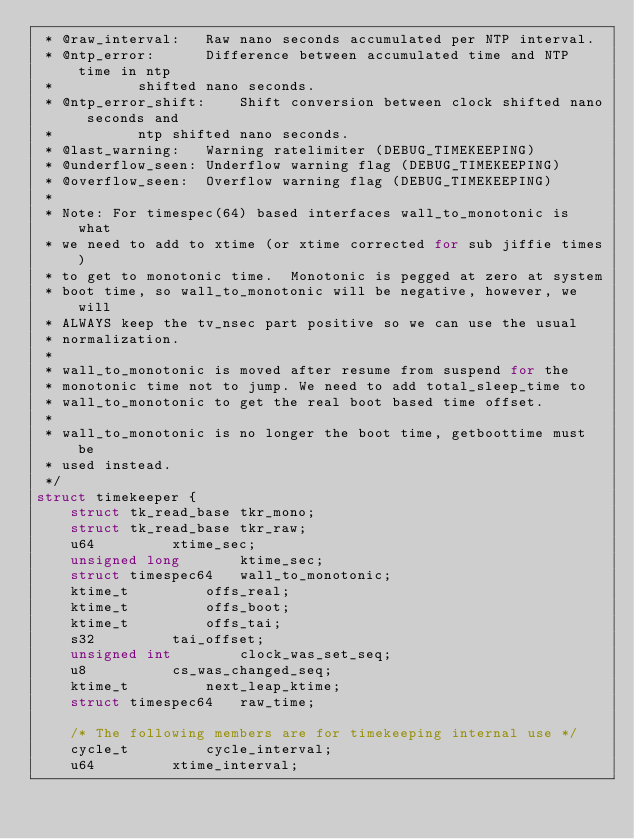Convert code to text. <code><loc_0><loc_0><loc_500><loc_500><_C_> * @raw_interval:	Raw nano seconds accumulated per NTP interval.
 * @ntp_error:		Difference between accumulated time and NTP time in ntp
 *			shifted nano seconds.
 * @ntp_error_shift:	Shift conversion between clock shifted nano seconds and
 *			ntp shifted nano seconds.
 * @last_warning:	Warning ratelimiter (DEBUG_TIMEKEEPING)
 * @underflow_seen:	Underflow warning flag (DEBUG_TIMEKEEPING)
 * @overflow_seen:	Overflow warning flag (DEBUG_TIMEKEEPING)
 *
 * Note: For timespec(64) based interfaces wall_to_monotonic is what
 * we need to add to xtime (or xtime corrected for sub jiffie times)
 * to get to monotonic time.  Monotonic is pegged at zero at system
 * boot time, so wall_to_monotonic will be negative, however, we will
 * ALWAYS keep the tv_nsec part positive so we can use the usual
 * normalization.
 *
 * wall_to_monotonic is moved after resume from suspend for the
 * monotonic time not to jump. We need to add total_sleep_time to
 * wall_to_monotonic to get the real boot based time offset.
 *
 * wall_to_monotonic is no longer the boot time, getboottime must be
 * used instead.
 */
struct timekeeper {
	struct tk_read_base	tkr_mono;
	struct tk_read_base	tkr_raw;
	u64			xtime_sec;
	unsigned long		ktime_sec;
	struct timespec64	wall_to_monotonic;
	ktime_t			offs_real;
	ktime_t			offs_boot;
	ktime_t			offs_tai;
	s32			tai_offset;
	unsigned int		clock_was_set_seq;
	u8			cs_was_changed_seq;
	ktime_t			next_leap_ktime;
	struct timespec64	raw_time;

	/* The following members are for timekeeping internal use */
	cycle_t			cycle_interval;
	u64			xtime_interval;</code> 